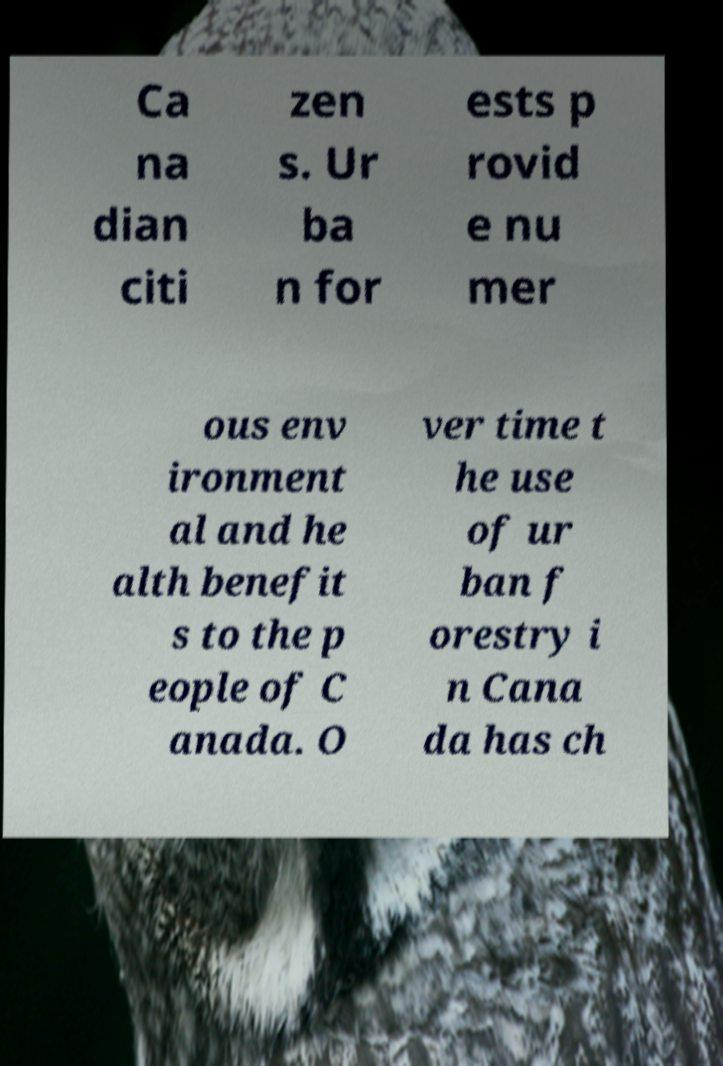I need the written content from this picture converted into text. Can you do that? Ca na dian citi zen s. Ur ba n for ests p rovid e nu mer ous env ironment al and he alth benefit s to the p eople of C anada. O ver time t he use of ur ban f orestry i n Cana da has ch 